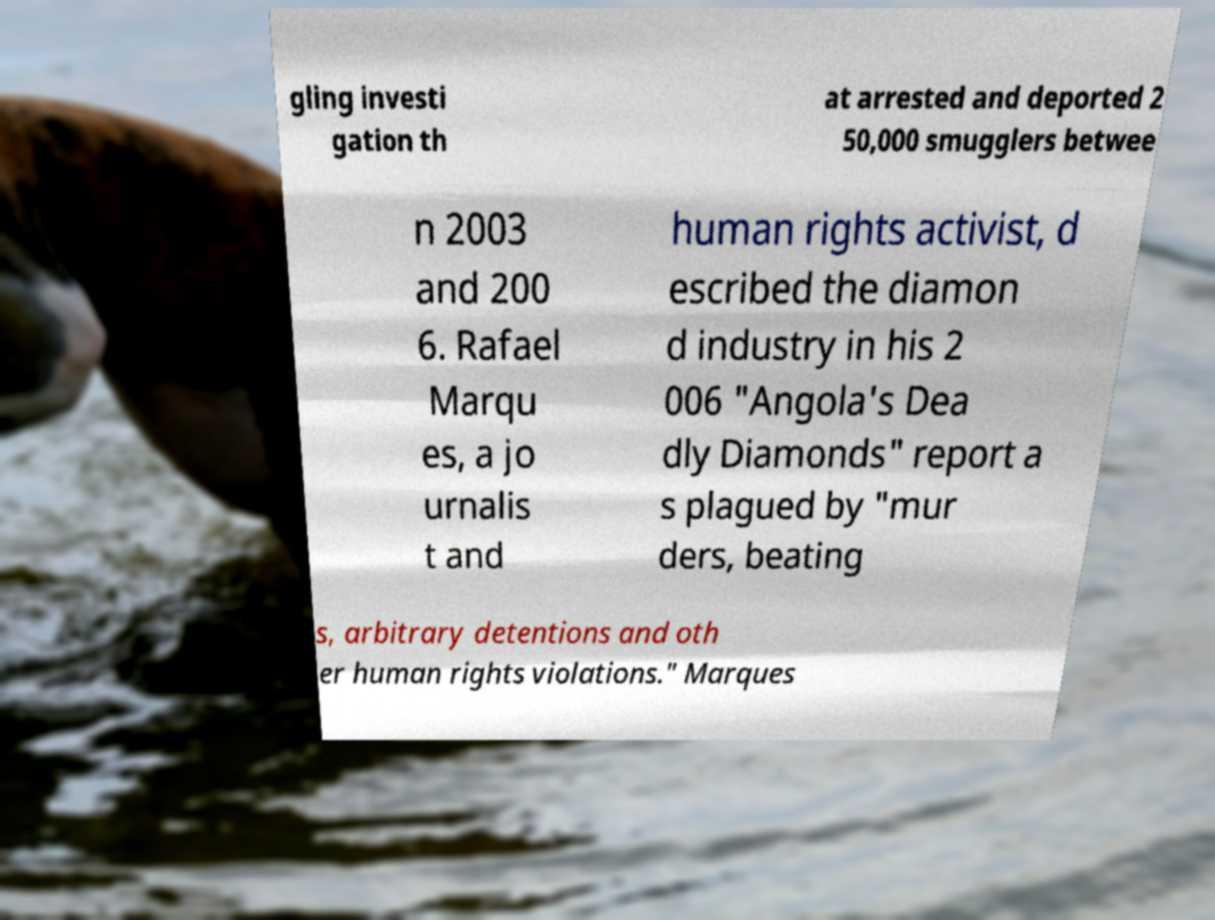Could you assist in decoding the text presented in this image and type it out clearly? gling investi gation th at arrested and deported 2 50,000 smugglers betwee n 2003 and 200 6. Rafael Marqu es, a jo urnalis t and human rights activist, d escribed the diamon d industry in his 2 006 "Angola's Dea dly Diamonds" report a s plagued by "mur ders, beating s, arbitrary detentions and oth er human rights violations." Marques 